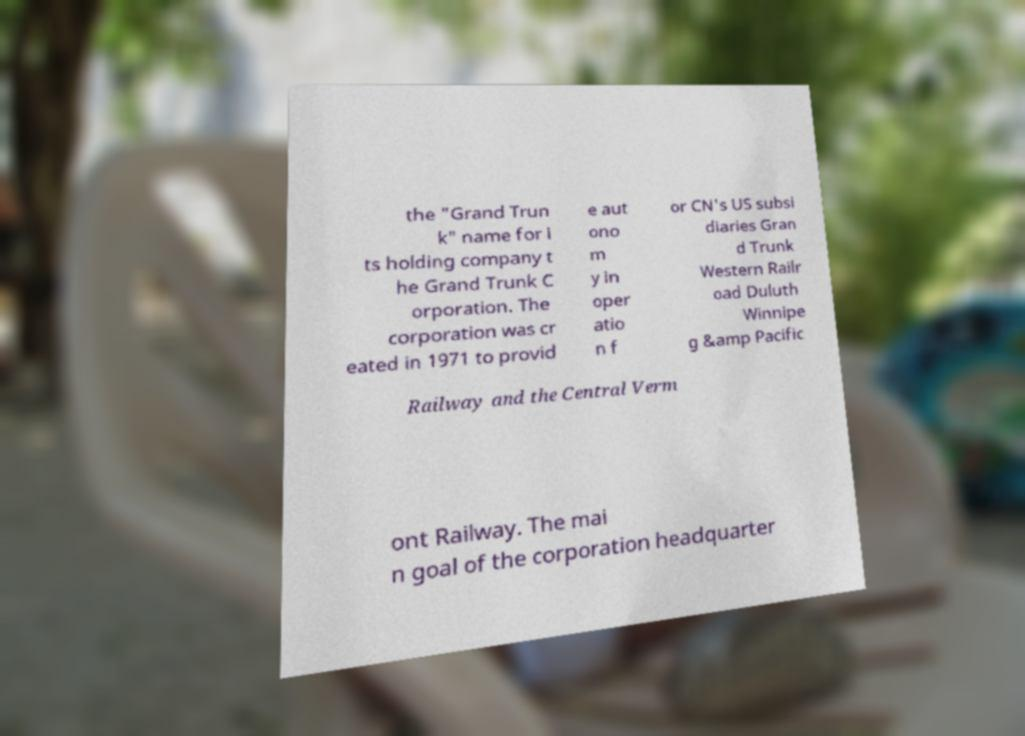Can you accurately transcribe the text from the provided image for me? the "Grand Trun k" name for i ts holding company t he Grand Trunk C orporation. The corporation was cr eated in 1971 to provid e aut ono m y in oper atio n f or CN's US subsi diaries Gran d Trunk Western Railr oad Duluth Winnipe g &amp Pacific Railway and the Central Verm ont Railway. The mai n goal of the corporation headquarter 